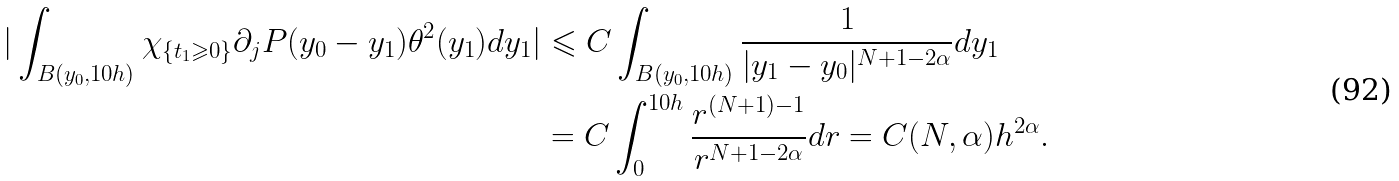<formula> <loc_0><loc_0><loc_500><loc_500>| \int _ { B ( y _ { 0 } , 1 0 h ) } \chi _ { \{ t _ { 1 } \geqslant 0 \} } \partial _ { j } P ( y _ { 0 } - y _ { 1 } ) \theta ^ { 2 } ( y _ { 1 } ) d y _ { 1 } | & \leqslant C \int _ { B ( y _ { 0 } , 1 0 h ) } \frac { 1 } { | y _ { 1 } - y _ { 0 } | ^ { N + 1 - 2 \alpha } } d y _ { 1 } \\ & = C \int _ { 0 } ^ { 1 0 h } \frac { r ^ { ( N + 1 ) - 1 } } { r ^ { N + 1 - 2 \alpha } } d r = C ( N , \alpha ) h ^ { 2 \alpha } .</formula> 